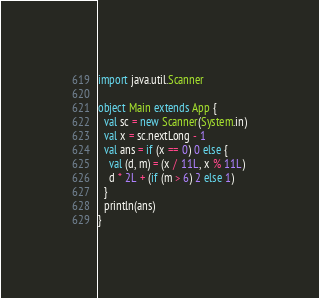<code> <loc_0><loc_0><loc_500><loc_500><_Scala_>import java.util.Scanner

object Main extends App {
  val sc = new Scanner(System.in)
  val x = sc.nextLong - 1
  val ans = if (x == 0) 0 else {
    val (d, m) = (x / 11L, x % 11L)
    d * 2L + (if (m > 6) 2 else 1)
  }
  println(ans)
}
</code> 